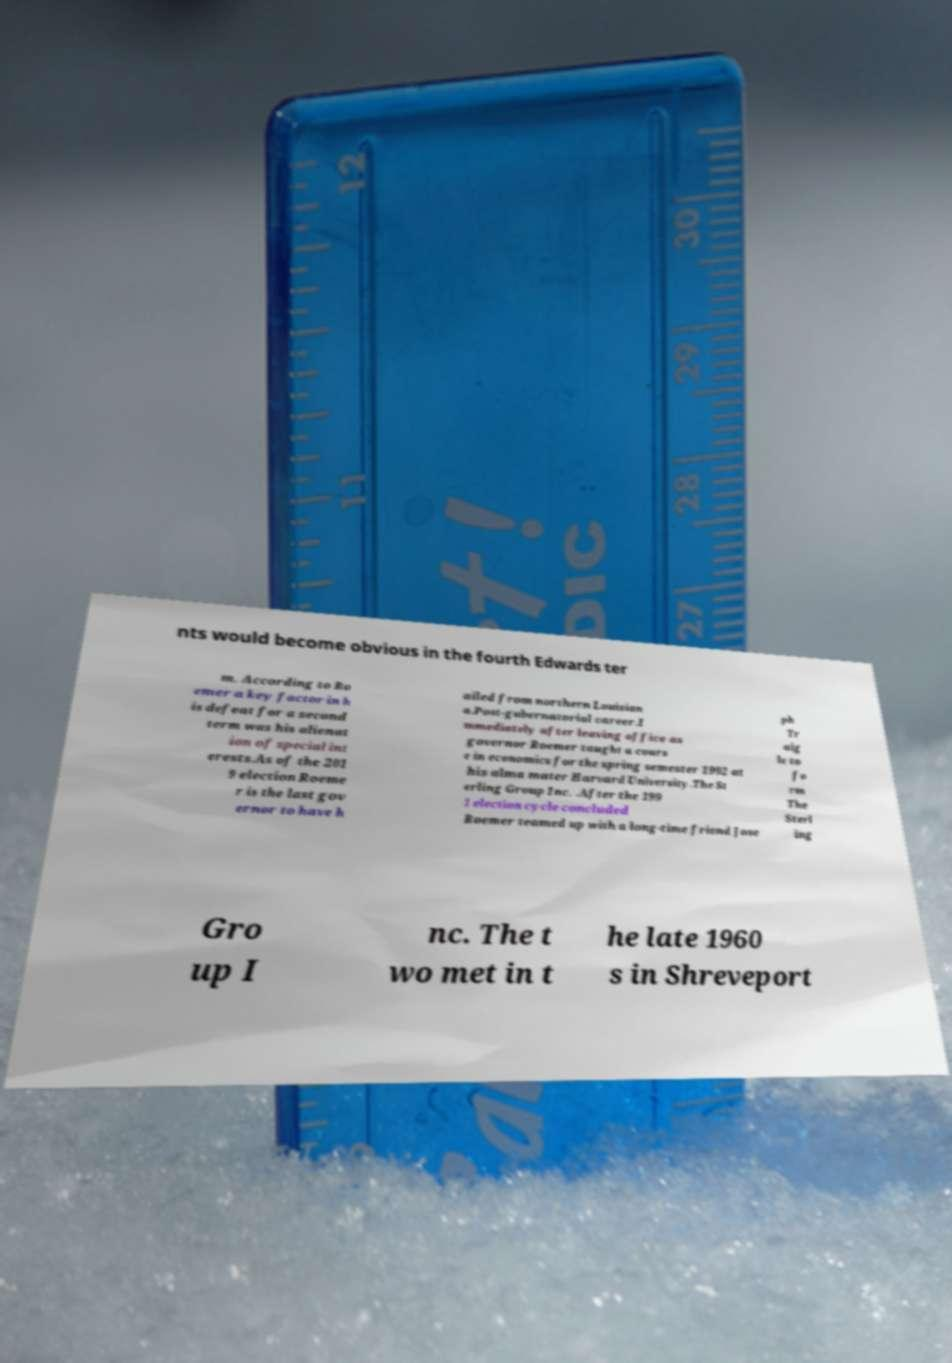There's text embedded in this image that I need extracted. Can you transcribe it verbatim? nts would become obvious in the fourth Edwards ter m. According to Ro emer a key factor in h is defeat for a second term was his alienat ion of special int erests.As of the 201 9 election Roeme r is the last gov ernor to have h ailed from northern Louisian a.Post-gubernatorial career.I mmediately after leaving office as governor Roemer taught a cours e in economics for the spring semester 1992 at his alma mater Harvard University.The St erling Group Inc. .After the 199 1 election cycle concluded Roemer teamed up with a long-time friend Jose ph Tr aig le to fo rm The Sterl ing Gro up I nc. The t wo met in t he late 1960 s in Shreveport 